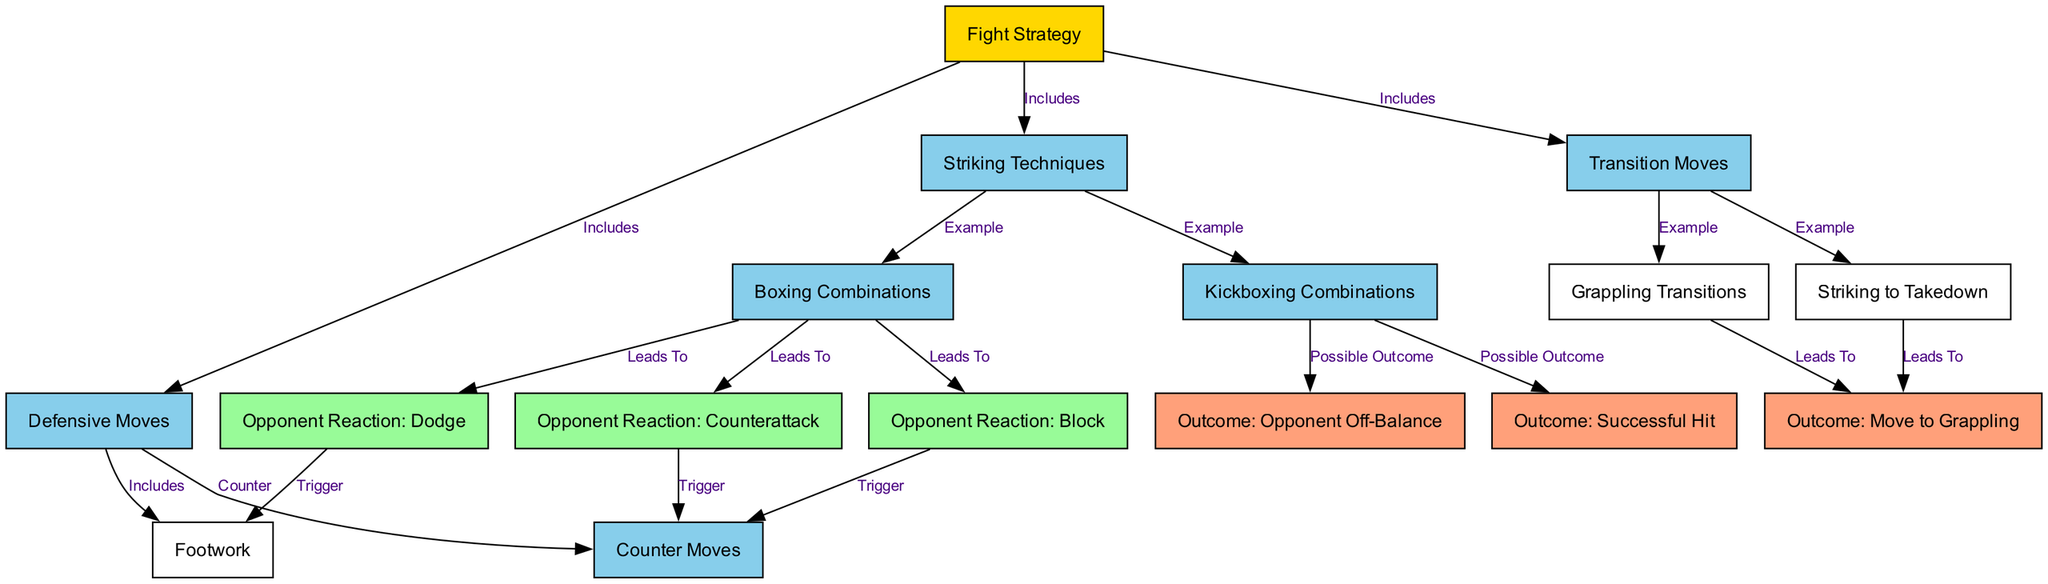What are the three main components of the Fight Strategy? The fight strategy includes striking techniques, defensive moves, and transition moves, which are indicated as the main branches from the "Fight Strategy" node.
Answer: Striking techniques, defensive moves, transition moves How many example techniques are provided under Striking Techniques? The "Striking Techniques" node leads to two examples, which are boxing combinations and kickboxing combinations, making it a total of two.
Answer: 2 What is the outcome of a successful kickboxing combination? The kickboxing combinations lead to two possible outcomes: a successful hit or the opponent being off-balance, as indicated in the flowchart.
Answer: Successful hit, opponent off-balance Which defensive move triggers footwork? The defensive move of dodging triggers the footwork technique, as shown in the diagram where "Dodging" leads to "Footwork".
Answer: Dodging If the opponent counters after a boxing combination, which move occurs? If the opponent reacts with a counterattack after a boxing combination, it leads to a counter move being triggered, according to the flow of the diagram.
Answer: Counter move How many nodes represent possible outcomes in the diagram? There are three nodes that represent possible outcomes: successful hit, opponent off-balance, and move to grappling, as derived from the edges linked to the outcomes.
Answer: 3 What is the relationship between transition moves and grappling transitions? Transition moves include grappling transitions as one of the examples, indicating a direct connection between the two in the flowchart.
Answer: Includes What leads to moving to grappling? Both striking to takedown and grappling transitions lead to moving to grappling, as indicated by the flow from these moves in the diagram.
Answer: Striking to takedown, grappling transitions 